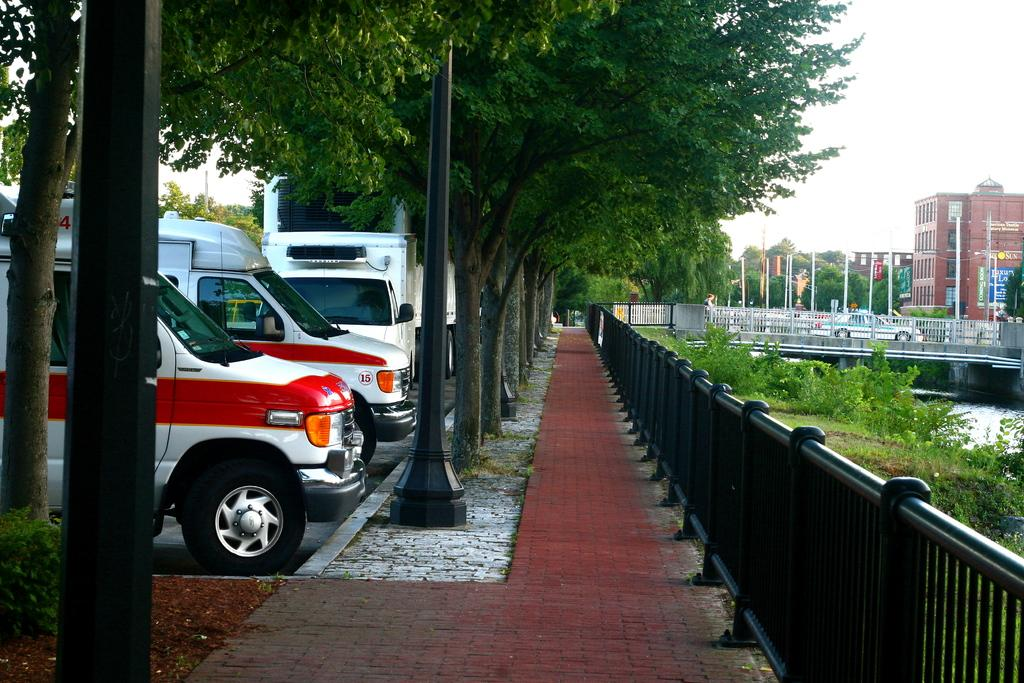What can be seen on the left side of the road in the image? There are vehicles parked on the left side of the road. What is located in the middle of the image? There are green trees in the middle of the image. What type of fencing is on the right side of the image? There is an iron fencing on the right side of the image. What is the color of the iron fencing? The iron fencing is black in color. Can you see a man wearing a veil in the image? There is no man or veil present in the image. 